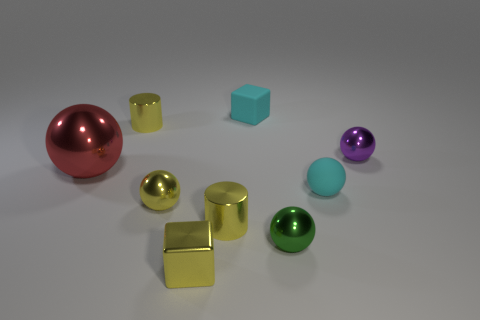Subtract all purple spheres. How many spheres are left? 4 Subtract all small yellow shiny balls. How many balls are left? 4 Subtract all green spheres. Subtract all red blocks. How many spheres are left? 4 Add 1 small gray cylinders. How many objects exist? 10 Subtract all cylinders. How many objects are left? 7 Add 9 big blue spheres. How many big blue spheres exist? 9 Subtract 0 gray cylinders. How many objects are left? 9 Subtract all tiny balls. Subtract all tiny balls. How many objects are left? 1 Add 7 tiny yellow metal balls. How many tiny yellow metal balls are left? 8 